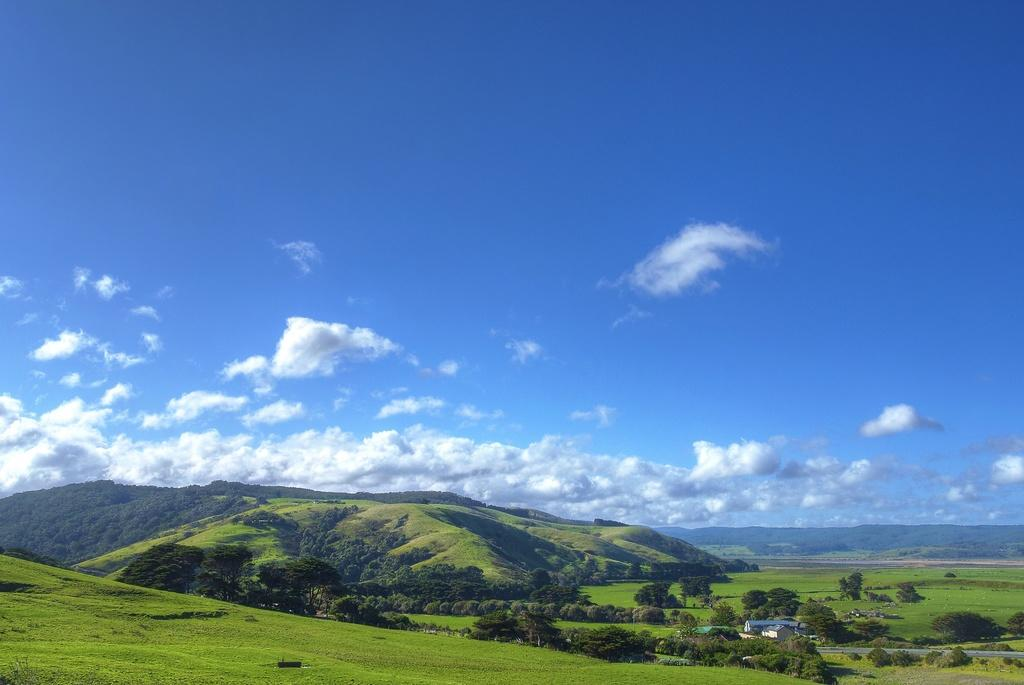What type of natural vegetation is present in the image? There is a group of trees in the image. What type of man-made structures can be seen in the image? There are buildings in the image. What type of geological formation is visible in the image? There are mountains in the image. What is visible in the background of the image? The sky is visible in the background of the image. What is the weather condition in the image? The sky appears to be cloudy in the image. What type of record is being played by the tank in the image? There is no tank or record present in the image. What class of students is observing the mountains in the image? There are no students or classes present in the image. 